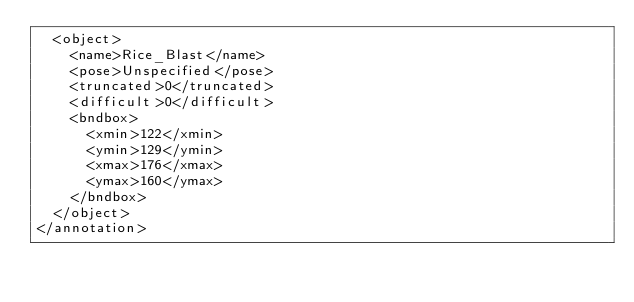<code> <loc_0><loc_0><loc_500><loc_500><_XML_>	<object>
		<name>Rice_Blast</name>
		<pose>Unspecified</pose>
		<truncated>0</truncated>
		<difficult>0</difficult>
		<bndbox>
			<xmin>122</xmin>
			<ymin>129</ymin>
			<xmax>176</xmax>
			<ymax>160</ymax>
		</bndbox>
	</object>
</annotation>
</code> 